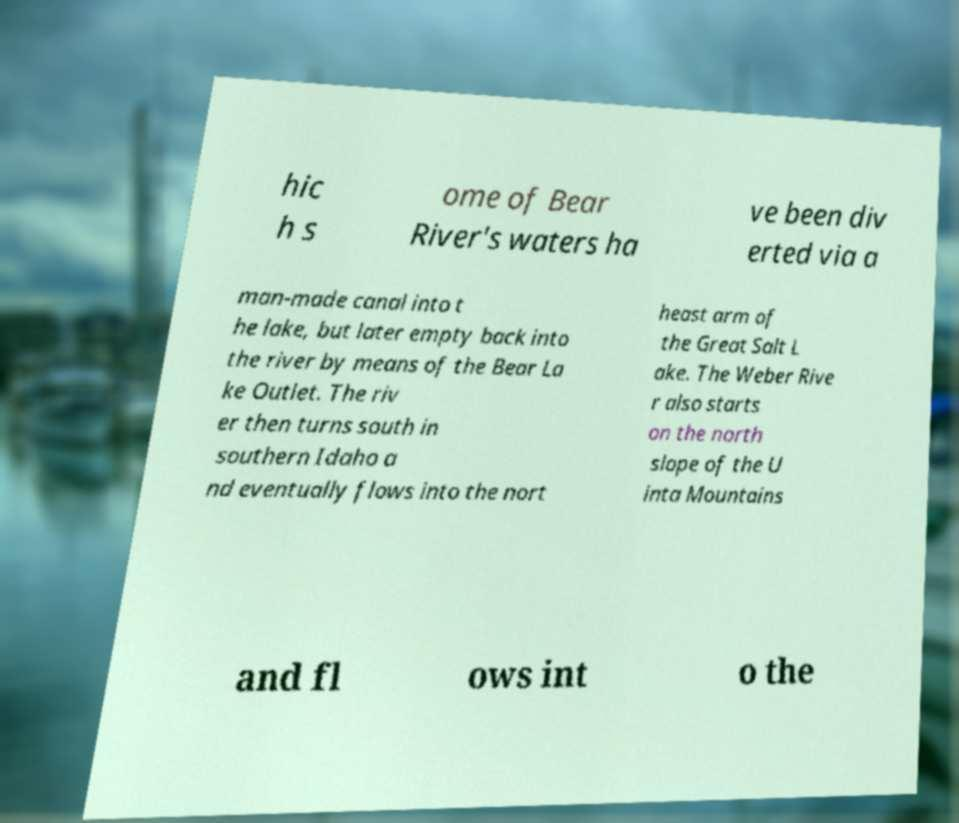Can you accurately transcribe the text from the provided image for me? hic h s ome of Bear River's waters ha ve been div erted via a man-made canal into t he lake, but later empty back into the river by means of the Bear La ke Outlet. The riv er then turns south in southern Idaho a nd eventually flows into the nort heast arm of the Great Salt L ake. The Weber Rive r also starts on the north slope of the U inta Mountains and fl ows int o the 